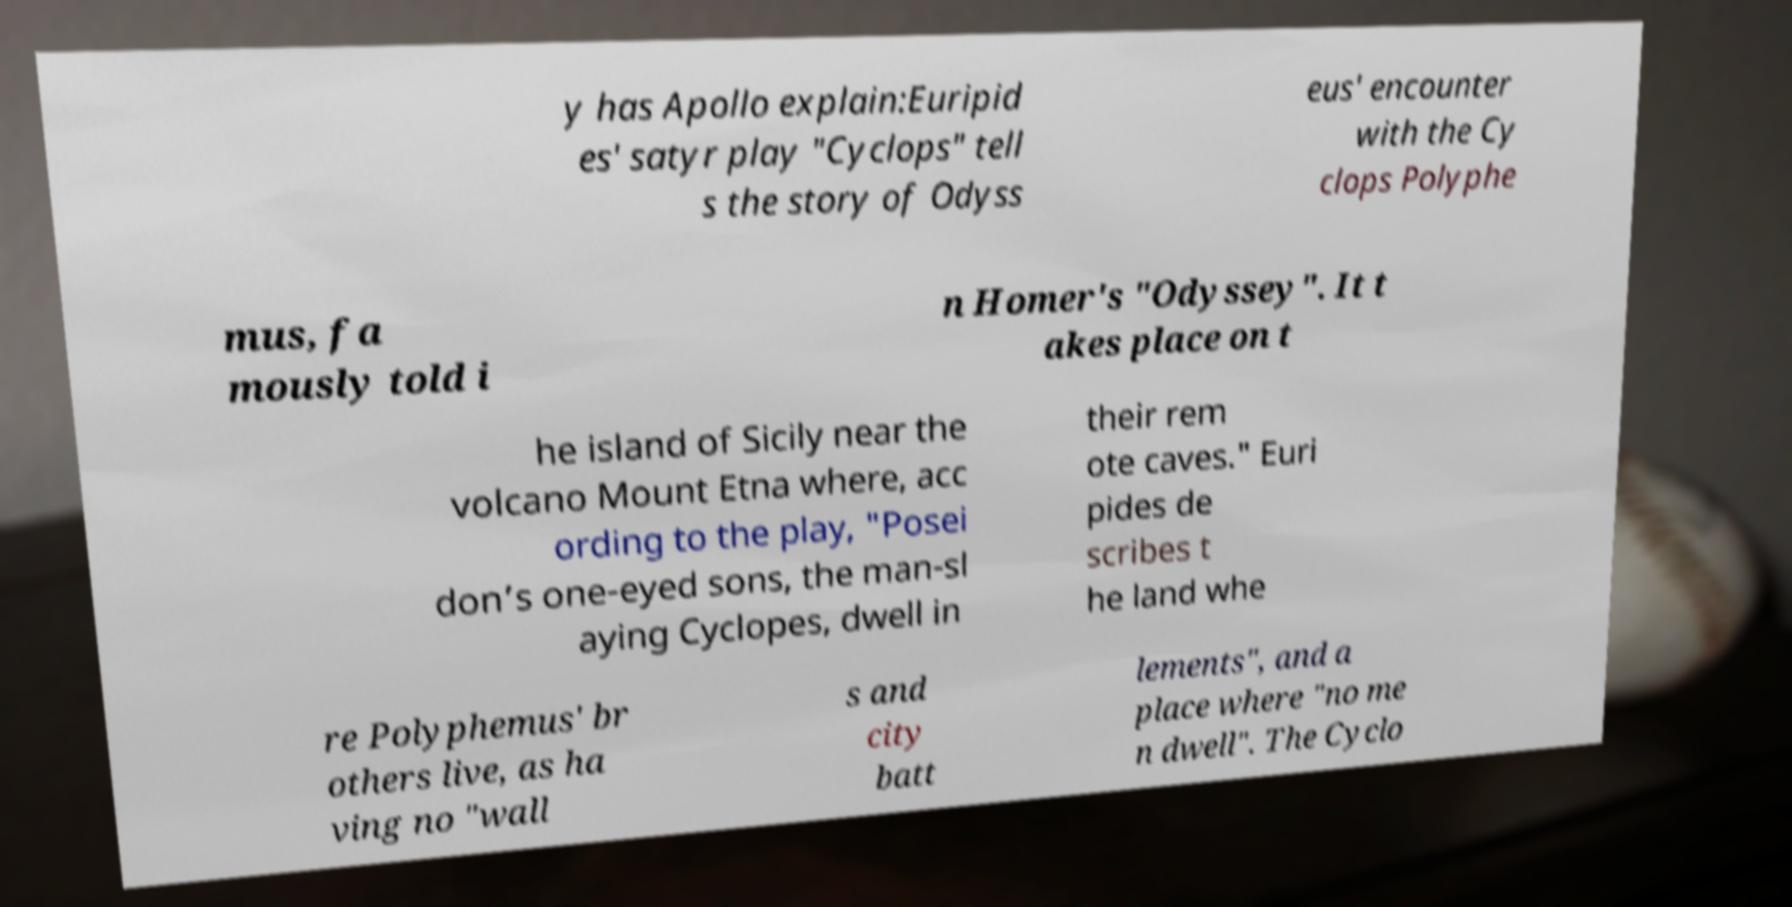Please read and relay the text visible in this image. What does it say? y has Apollo explain:Euripid es' satyr play "Cyclops" tell s the story of Odyss eus' encounter with the Cy clops Polyphe mus, fa mously told i n Homer's "Odyssey". It t akes place on t he island of Sicily near the volcano Mount Etna where, acc ording to the play, "Posei don’s one-eyed sons, the man-sl aying Cyclopes, dwell in their rem ote caves." Euri pides de scribes t he land whe re Polyphemus' br others live, as ha ving no "wall s and city batt lements", and a place where "no me n dwell". The Cyclo 